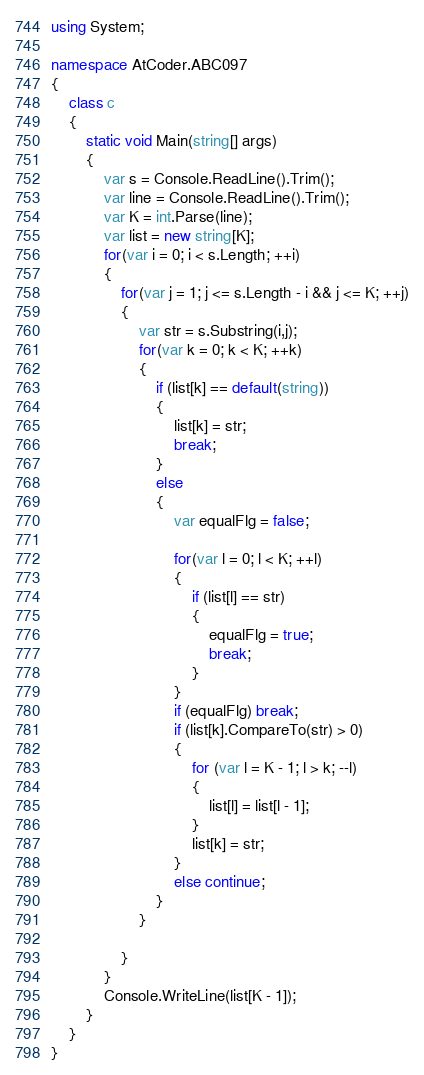<code> <loc_0><loc_0><loc_500><loc_500><_C#_>using System;

namespace AtCoder.ABC097
{
    class c
    {
        static void Main(string[] args)
        {
            var s = Console.ReadLine().Trim();
            var line = Console.ReadLine().Trim();
            var K = int.Parse(line);
            var list = new string[K];
            for(var i = 0; i < s.Length; ++i)
            {
                for(var j = 1; j <= s.Length - i && j <= K; ++j)
                {
                    var str = s.Substring(i,j);
                    for(var k = 0; k < K; ++k)
                    {
                        if (list[k] == default(string))
                        {
                            list[k] = str;
                            break;
                        }
                        else
                        {
                            var equalFlg = false;
                            
                            for(var l = 0; l < K; ++l)
                            {
                                if (list[l] == str)
                                {
                                    equalFlg = true;
                                    break;
                                }
                            }
                            if (equalFlg) break;
                            if (list[k].CompareTo(str) > 0)
                            {
                                for (var l = K - 1; l > k; --l)
                                {
                                    list[l] = list[l - 1];
                                }
                                list[k] = str;
                            }
                            else continue;
                        }
                    }

                }
            }
            Console.WriteLine(list[K - 1]);
        }
    }
}
</code> 